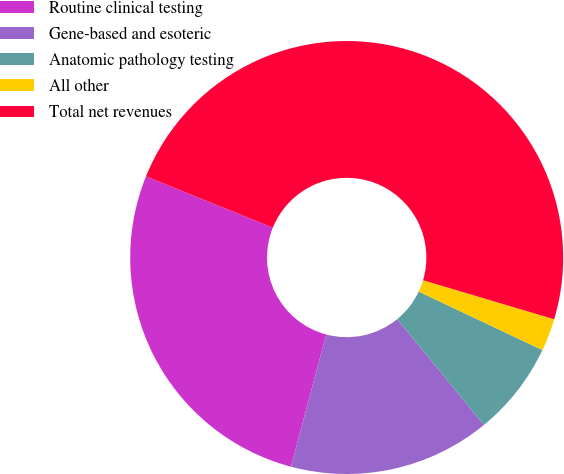Convert chart to OTSL. <chart><loc_0><loc_0><loc_500><loc_500><pie_chart><fcel>Routine clinical testing<fcel>Gene-based and esoteric<fcel>Anatomic pathology testing<fcel>All other<fcel>Total net revenues<nl><fcel>26.97%<fcel>15.07%<fcel>7.04%<fcel>2.43%<fcel>48.49%<nl></chart> 